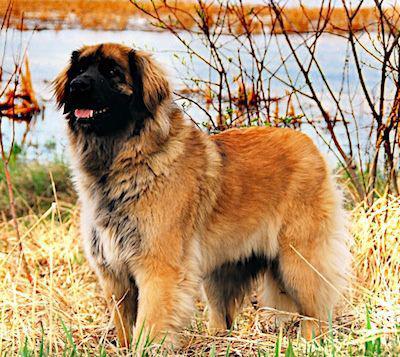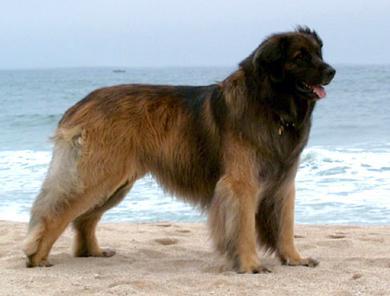The first image is the image on the left, the second image is the image on the right. Examine the images to the left and right. Is the description "There is a large body of water in the background of at least one of the pictures." accurate? Answer yes or no. Yes. The first image is the image on the left, the second image is the image on the right. Examine the images to the left and right. Is the description "In one image, a woman in glasses is on the left of a dog that is sitting up, and the other image includes a dog standing in profile on grass." accurate? Answer yes or no. No. 